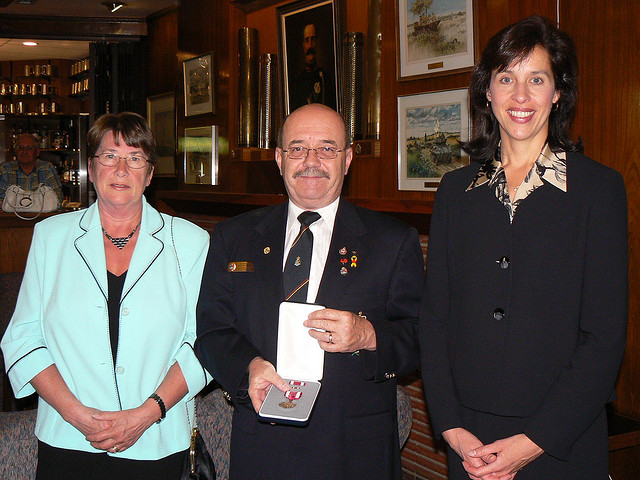How many people is in the photo? 3 